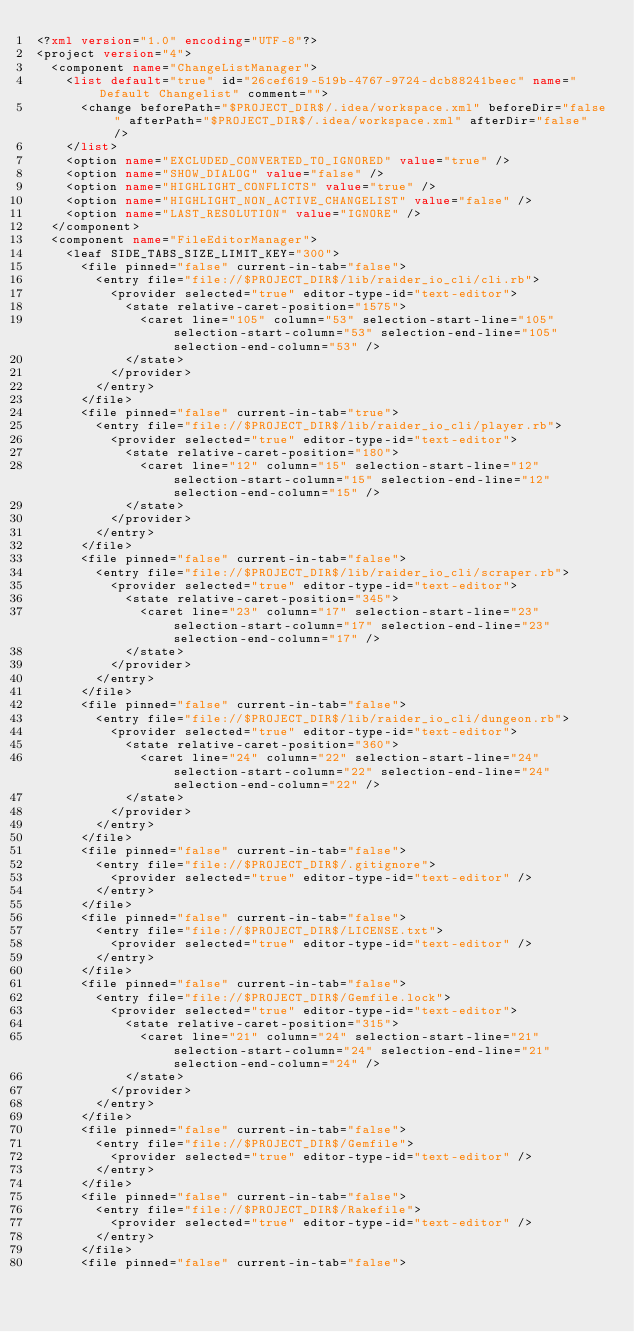Convert code to text. <code><loc_0><loc_0><loc_500><loc_500><_XML_><?xml version="1.0" encoding="UTF-8"?>
<project version="4">
  <component name="ChangeListManager">
    <list default="true" id="26cef619-519b-4767-9724-dcb88241beec" name="Default Changelist" comment="">
      <change beforePath="$PROJECT_DIR$/.idea/workspace.xml" beforeDir="false" afterPath="$PROJECT_DIR$/.idea/workspace.xml" afterDir="false" />
    </list>
    <option name="EXCLUDED_CONVERTED_TO_IGNORED" value="true" />
    <option name="SHOW_DIALOG" value="false" />
    <option name="HIGHLIGHT_CONFLICTS" value="true" />
    <option name="HIGHLIGHT_NON_ACTIVE_CHANGELIST" value="false" />
    <option name="LAST_RESOLUTION" value="IGNORE" />
  </component>
  <component name="FileEditorManager">
    <leaf SIDE_TABS_SIZE_LIMIT_KEY="300">
      <file pinned="false" current-in-tab="false">
        <entry file="file://$PROJECT_DIR$/lib/raider_io_cli/cli.rb">
          <provider selected="true" editor-type-id="text-editor">
            <state relative-caret-position="1575">
              <caret line="105" column="53" selection-start-line="105" selection-start-column="53" selection-end-line="105" selection-end-column="53" />
            </state>
          </provider>
        </entry>
      </file>
      <file pinned="false" current-in-tab="true">
        <entry file="file://$PROJECT_DIR$/lib/raider_io_cli/player.rb">
          <provider selected="true" editor-type-id="text-editor">
            <state relative-caret-position="180">
              <caret line="12" column="15" selection-start-line="12" selection-start-column="15" selection-end-line="12" selection-end-column="15" />
            </state>
          </provider>
        </entry>
      </file>
      <file pinned="false" current-in-tab="false">
        <entry file="file://$PROJECT_DIR$/lib/raider_io_cli/scraper.rb">
          <provider selected="true" editor-type-id="text-editor">
            <state relative-caret-position="345">
              <caret line="23" column="17" selection-start-line="23" selection-start-column="17" selection-end-line="23" selection-end-column="17" />
            </state>
          </provider>
        </entry>
      </file>
      <file pinned="false" current-in-tab="false">
        <entry file="file://$PROJECT_DIR$/lib/raider_io_cli/dungeon.rb">
          <provider selected="true" editor-type-id="text-editor">
            <state relative-caret-position="360">
              <caret line="24" column="22" selection-start-line="24" selection-start-column="22" selection-end-line="24" selection-end-column="22" />
            </state>
          </provider>
        </entry>
      </file>
      <file pinned="false" current-in-tab="false">
        <entry file="file://$PROJECT_DIR$/.gitignore">
          <provider selected="true" editor-type-id="text-editor" />
        </entry>
      </file>
      <file pinned="false" current-in-tab="false">
        <entry file="file://$PROJECT_DIR$/LICENSE.txt">
          <provider selected="true" editor-type-id="text-editor" />
        </entry>
      </file>
      <file pinned="false" current-in-tab="false">
        <entry file="file://$PROJECT_DIR$/Gemfile.lock">
          <provider selected="true" editor-type-id="text-editor">
            <state relative-caret-position="315">
              <caret line="21" column="24" selection-start-line="21" selection-start-column="24" selection-end-line="21" selection-end-column="24" />
            </state>
          </provider>
        </entry>
      </file>
      <file pinned="false" current-in-tab="false">
        <entry file="file://$PROJECT_DIR$/Gemfile">
          <provider selected="true" editor-type-id="text-editor" />
        </entry>
      </file>
      <file pinned="false" current-in-tab="false">
        <entry file="file://$PROJECT_DIR$/Rakefile">
          <provider selected="true" editor-type-id="text-editor" />
        </entry>
      </file>
      <file pinned="false" current-in-tab="false"></code> 